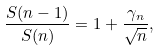Convert formula to latex. <formula><loc_0><loc_0><loc_500><loc_500>\frac { S ( n - 1 ) } { S ( n ) } = 1 + \frac { \gamma _ { n } } { \sqrt { n } } ,</formula> 